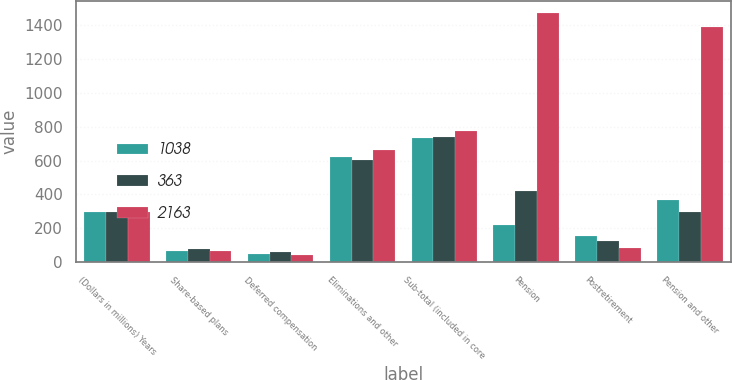<chart> <loc_0><loc_0><loc_500><loc_500><stacked_bar_chart><ecel><fcel>(Dollars in millions) Years<fcel>Share-based plans<fcel>Deferred compensation<fcel>Eliminations and other<fcel>Sub-total (included in core<fcel>Pension<fcel>Postretirement<fcel>Pension and other<nl><fcel>1038<fcel>298<fcel>66<fcel>46<fcel>621<fcel>733<fcel>217<fcel>153<fcel>370<nl><fcel>363<fcel>298<fcel>76<fcel>63<fcel>601<fcel>740<fcel>421<fcel>123<fcel>298<nl><fcel>2163<fcel>298<fcel>67<fcel>44<fcel>665<fcel>776<fcel>1469<fcel>82<fcel>1387<nl></chart> 